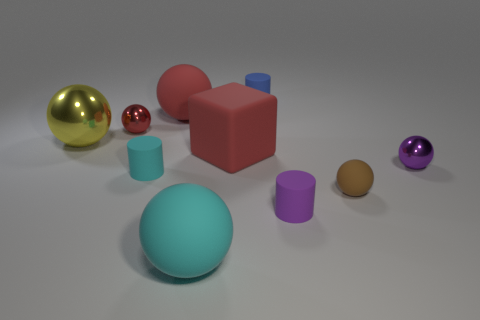Subtract all purple balls. How many balls are left? 5 Subtract all red rubber balls. How many balls are left? 5 Subtract all blue balls. Subtract all blue cubes. How many balls are left? 6 Subtract all blocks. How many objects are left? 9 Add 7 red metallic spheres. How many red metallic spheres are left? 8 Add 2 small green matte things. How many small green matte things exist? 2 Subtract 0 gray spheres. How many objects are left? 10 Subtract all tiny blue rubber things. Subtract all yellow things. How many objects are left? 8 